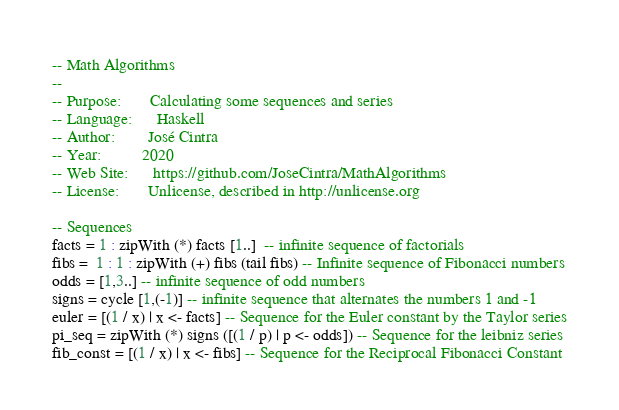Convert code to text. <code><loc_0><loc_0><loc_500><loc_500><_Haskell_>-- Math Algorithms
--
-- Purpose:       Calculating some sequences and series
-- Language:      Haskell
-- Author:        José Cintra
-- Year:          2020
-- Web Site:      https://github.com/JoseCintra/MathAlgorithms
-- License:       Unlicense, described in http://unlicense.org

-- Sequences 
facts = 1 : zipWith (*) facts [1..]  -- infinite sequence of factorials
fibs =  1 : 1 : zipWith (+) fibs (tail fibs) -- Infinite sequence of Fibonacci numbers
odds = [1,3..] -- infinite sequence of odd numbers
signs = cycle [1,(-1)] -- infinite sequence that alternates the numbers 1 and -1
euler = [(1 / x) | x <- facts] -- Sequence for the Euler constant by the Taylor series
pi_seq = zipWith (*) signs ([(1 / p) | p <- odds]) -- Sequence for the leibniz series 
fib_const = [(1 / x) | x <- fibs] -- Sequence for the Reciprocal Fibonacci Constant</code> 